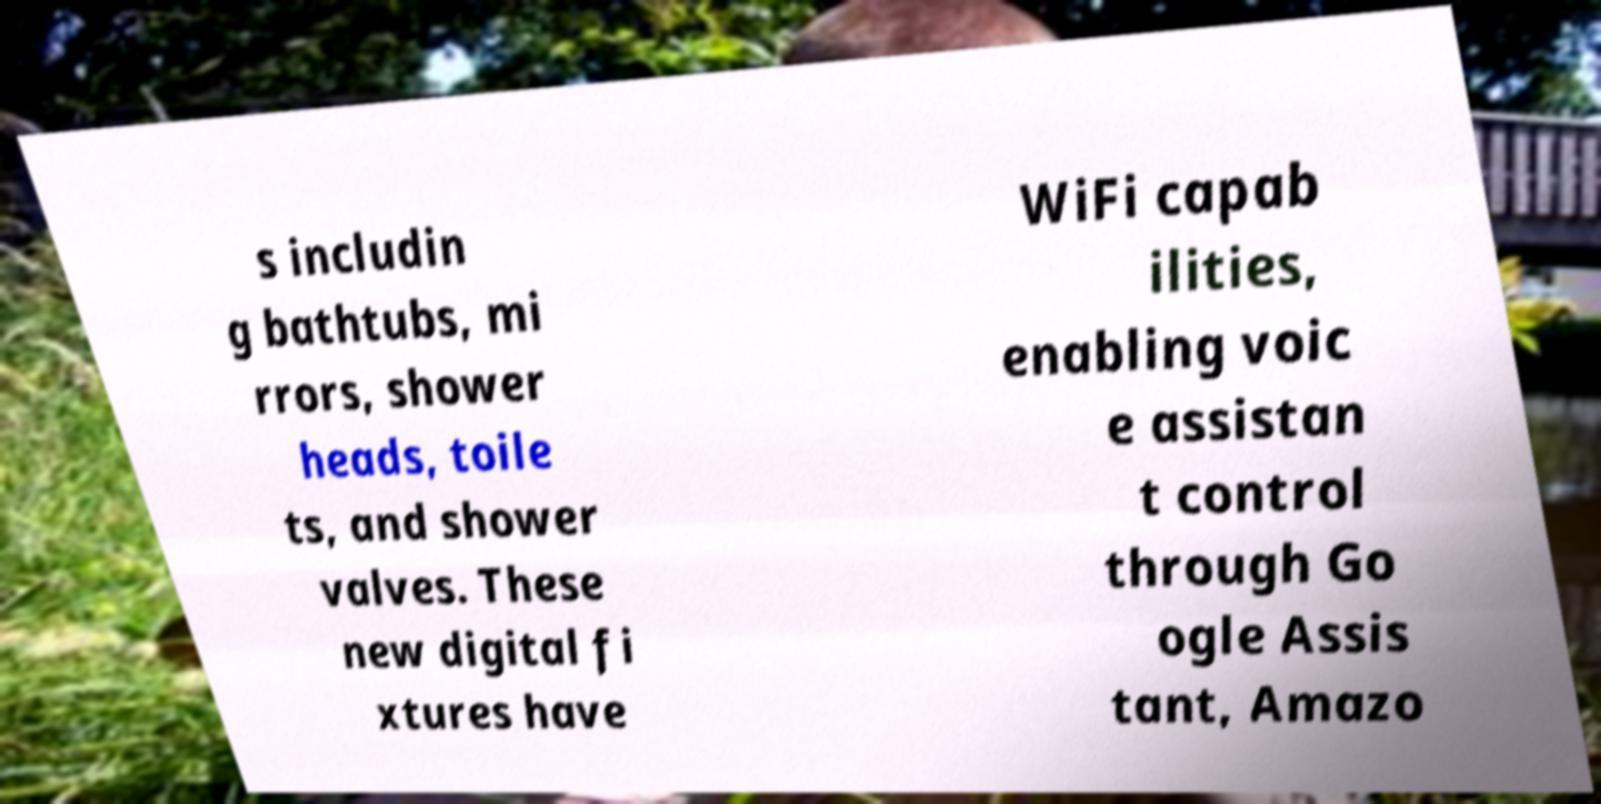Can you read and provide the text displayed in the image?This photo seems to have some interesting text. Can you extract and type it out for me? s includin g bathtubs, mi rrors, shower heads, toile ts, and shower valves. These new digital fi xtures have WiFi capab ilities, enabling voic e assistan t control through Go ogle Assis tant, Amazo 